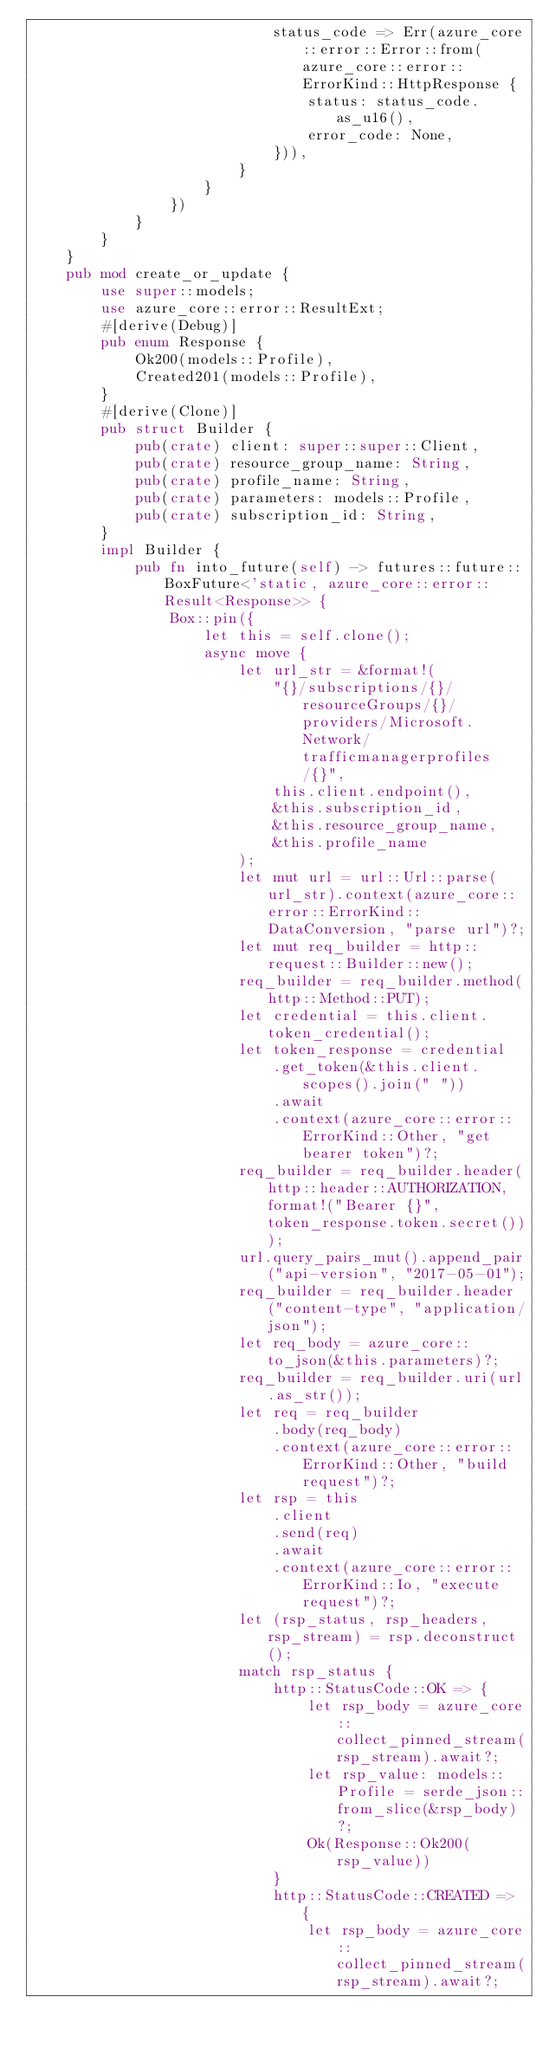<code> <loc_0><loc_0><loc_500><loc_500><_Rust_>                            status_code => Err(azure_core::error::Error::from(azure_core::error::ErrorKind::HttpResponse {
                                status: status_code.as_u16(),
                                error_code: None,
                            })),
                        }
                    }
                })
            }
        }
    }
    pub mod create_or_update {
        use super::models;
        use azure_core::error::ResultExt;
        #[derive(Debug)]
        pub enum Response {
            Ok200(models::Profile),
            Created201(models::Profile),
        }
        #[derive(Clone)]
        pub struct Builder {
            pub(crate) client: super::super::Client,
            pub(crate) resource_group_name: String,
            pub(crate) profile_name: String,
            pub(crate) parameters: models::Profile,
            pub(crate) subscription_id: String,
        }
        impl Builder {
            pub fn into_future(self) -> futures::future::BoxFuture<'static, azure_core::error::Result<Response>> {
                Box::pin({
                    let this = self.clone();
                    async move {
                        let url_str = &format!(
                            "{}/subscriptions/{}/resourceGroups/{}/providers/Microsoft.Network/trafficmanagerprofiles/{}",
                            this.client.endpoint(),
                            &this.subscription_id,
                            &this.resource_group_name,
                            &this.profile_name
                        );
                        let mut url = url::Url::parse(url_str).context(azure_core::error::ErrorKind::DataConversion, "parse url")?;
                        let mut req_builder = http::request::Builder::new();
                        req_builder = req_builder.method(http::Method::PUT);
                        let credential = this.client.token_credential();
                        let token_response = credential
                            .get_token(&this.client.scopes().join(" "))
                            .await
                            .context(azure_core::error::ErrorKind::Other, "get bearer token")?;
                        req_builder = req_builder.header(http::header::AUTHORIZATION, format!("Bearer {}", token_response.token.secret()));
                        url.query_pairs_mut().append_pair("api-version", "2017-05-01");
                        req_builder = req_builder.header("content-type", "application/json");
                        let req_body = azure_core::to_json(&this.parameters)?;
                        req_builder = req_builder.uri(url.as_str());
                        let req = req_builder
                            .body(req_body)
                            .context(azure_core::error::ErrorKind::Other, "build request")?;
                        let rsp = this
                            .client
                            .send(req)
                            .await
                            .context(azure_core::error::ErrorKind::Io, "execute request")?;
                        let (rsp_status, rsp_headers, rsp_stream) = rsp.deconstruct();
                        match rsp_status {
                            http::StatusCode::OK => {
                                let rsp_body = azure_core::collect_pinned_stream(rsp_stream).await?;
                                let rsp_value: models::Profile = serde_json::from_slice(&rsp_body)?;
                                Ok(Response::Ok200(rsp_value))
                            }
                            http::StatusCode::CREATED => {
                                let rsp_body = azure_core::collect_pinned_stream(rsp_stream).await?;</code> 